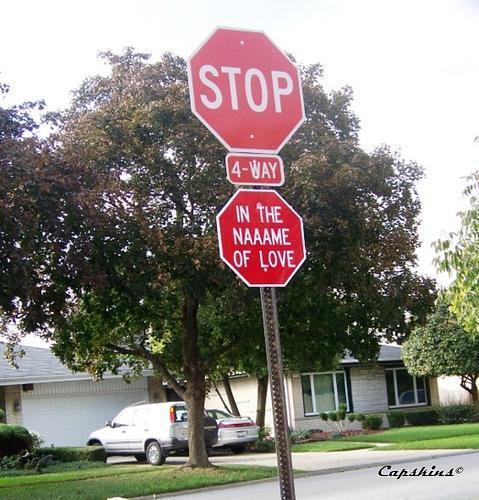How many stop signs can you see?
Give a very brief answer. 1. How many boats are not docked in this scene?
Give a very brief answer. 0. 